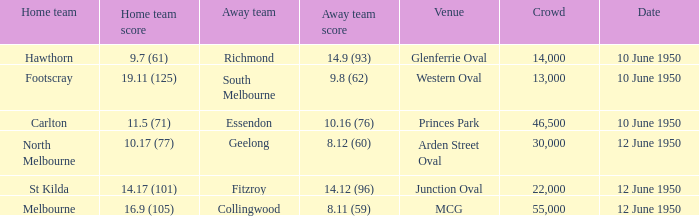Who was the away team when the VFL played at MCG? Collingwood. 